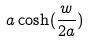<formula> <loc_0><loc_0><loc_500><loc_500>a \cosh ( \frac { w } { 2 a } )</formula> 